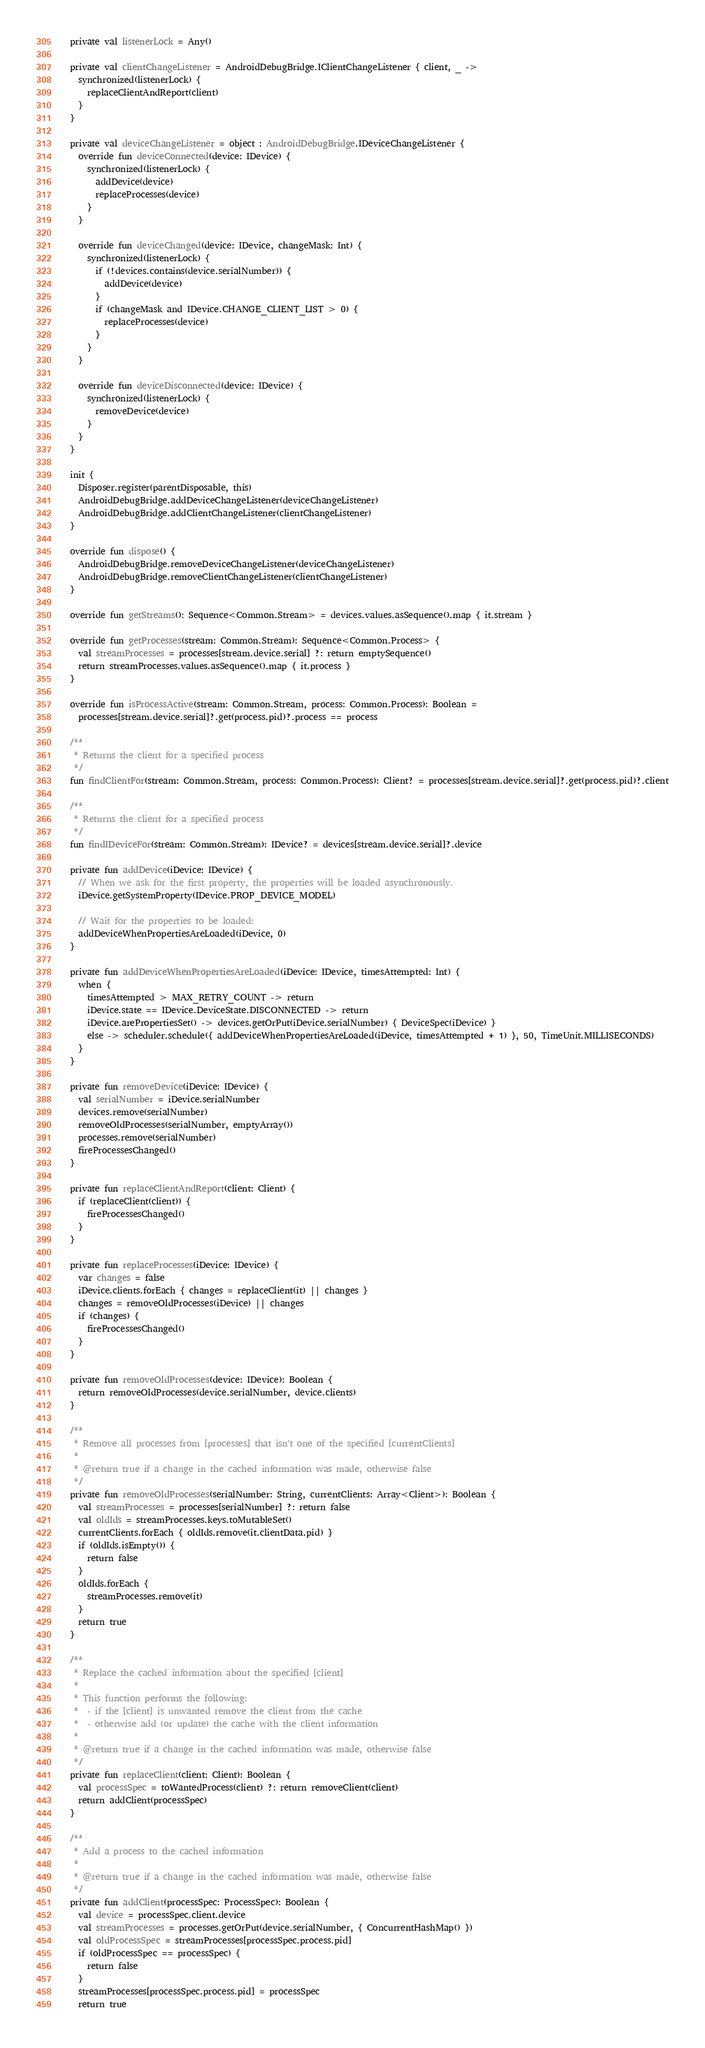Convert code to text. <code><loc_0><loc_0><loc_500><loc_500><_Kotlin_>
  private val listenerLock = Any()

  private val clientChangeListener = AndroidDebugBridge.IClientChangeListener { client, _ ->
    synchronized(listenerLock) {
      replaceClientAndReport(client)
    }
  }

  private val deviceChangeListener = object : AndroidDebugBridge.IDeviceChangeListener {
    override fun deviceConnected(device: IDevice) {
      synchronized(listenerLock) {
        addDevice(device)
        replaceProcesses(device)
      }
    }

    override fun deviceChanged(device: IDevice, changeMask: Int) {
      synchronized(listenerLock) {
        if (!devices.contains(device.serialNumber)) {
          addDevice(device)
        }
        if (changeMask and IDevice.CHANGE_CLIENT_LIST > 0) {
          replaceProcesses(device)
        }
      }
    }

    override fun deviceDisconnected(device: IDevice) {
      synchronized(listenerLock) {
        removeDevice(device)
      }
    }
  }

  init {
    Disposer.register(parentDisposable, this)
    AndroidDebugBridge.addDeviceChangeListener(deviceChangeListener)
    AndroidDebugBridge.addClientChangeListener(clientChangeListener)
  }

  override fun dispose() {
    AndroidDebugBridge.removeDeviceChangeListener(deviceChangeListener)
    AndroidDebugBridge.removeClientChangeListener(clientChangeListener)
  }

  override fun getStreams(): Sequence<Common.Stream> = devices.values.asSequence().map { it.stream }

  override fun getProcesses(stream: Common.Stream): Sequence<Common.Process> {
    val streamProcesses = processes[stream.device.serial] ?: return emptySequence()
    return streamProcesses.values.asSequence().map { it.process }
  }

  override fun isProcessActive(stream: Common.Stream, process: Common.Process): Boolean =
    processes[stream.device.serial]?.get(process.pid)?.process == process

  /**
   * Returns the client for a specified process
   */
  fun findClientFor(stream: Common.Stream, process: Common.Process): Client? = processes[stream.device.serial]?.get(process.pid)?.client

  /**
   * Returns the client for a specified process
   */
  fun findIDeviceFor(stream: Common.Stream): IDevice? = devices[stream.device.serial]?.device

  private fun addDevice(iDevice: IDevice) {
    // When we ask for the first property, the properties will be loaded asynchronously.
    iDevice.getSystemProperty(IDevice.PROP_DEVICE_MODEL)

    // Wait for the properties to be loaded:
    addDeviceWhenPropertiesAreLoaded(iDevice, 0)
  }

  private fun addDeviceWhenPropertiesAreLoaded(iDevice: IDevice, timesAttempted: Int) {
    when {
      timesAttempted > MAX_RETRY_COUNT -> return
      iDevice.state == IDevice.DeviceState.DISCONNECTED -> return
      iDevice.arePropertiesSet() -> devices.getOrPut(iDevice.serialNumber) { DeviceSpec(iDevice) }
      else -> scheduler.schedule({ addDeviceWhenPropertiesAreLoaded(iDevice, timesAttempted + 1) }, 50, TimeUnit.MILLISECONDS)
    }
  }

  private fun removeDevice(iDevice: IDevice) {
    val serialNumber = iDevice.serialNumber
    devices.remove(serialNumber)
    removeOldProcesses(serialNumber, emptyArray())
    processes.remove(serialNumber)
    fireProcessesChanged()
  }

  private fun replaceClientAndReport(client: Client) {
    if (replaceClient(client)) {
      fireProcessesChanged()
    }
  }

  private fun replaceProcesses(iDevice: IDevice) {
    var changes = false
    iDevice.clients.forEach { changes = replaceClient(it) || changes }
    changes = removeOldProcesses(iDevice) || changes
    if (changes) {
      fireProcessesChanged()
    }
  }

  private fun removeOldProcesses(device: IDevice): Boolean {
    return removeOldProcesses(device.serialNumber, device.clients)
  }

  /**
   * Remove all processes from [processes] that isn't one of the specified [currentClients]
   *
   * @return true if a change in the cached information was made, otherwise false
   */
  private fun removeOldProcesses(serialNumber: String, currentClients: Array<Client>): Boolean {
    val streamProcesses = processes[serialNumber] ?: return false
    val oldIds = streamProcesses.keys.toMutableSet()
    currentClients.forEach { oldIds.remove(it.clientData.pid) }
    if (oldIds.isEmpty()) {
      return false
    }
    oldIds.forEach {
      streamProcesses.remove(it)
    }
    return true
  }

  /**
   * Replace the cached information about the specified [client]
   *
   * This function performs the following:
   *  - if the [client] is unwanted remove the client from the cache
   *  - otherwise add (or update) the cache with the client information
   *
   * @return true if a change in the cached information was made, otherwise false
   */
  private fun replaceClient(client: Client): Boolean {
    val processSpec = toWantedProcess(client) ?: return removeClient(client)
    return addClient(processSpec)
  }

  /**
   * Add a process to the cached information
   *
   * @return true if a change in the cached information was made, otherwise false
   */
  private fun addClient(processSpec: ProcessSpec): Boolean {
    val device = processSpec.client.device
    val streamProcesses = processes.getOrPut(device.serialNumber, { ConcurrentHashMap() })
    val oldProcessSpec = streamProcesses[processSpec.process.pid]
    if (oldProcessSpec == processSpec) {
      return false
    }
    streamProcesses[processSpec.process.pid] = processSpec
    return true</code> 